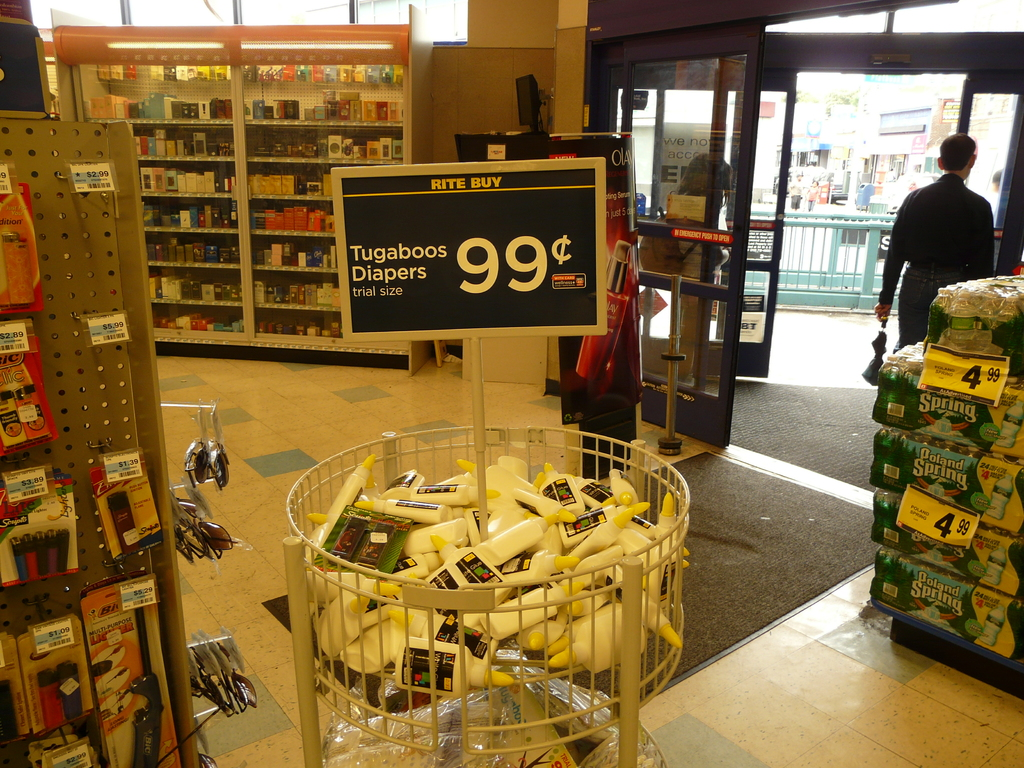What are some of the other items on sale in the image? In addition to Tugaboos Diapers with a sign indicating a price tag of $4.99, there are cases of Poland Spring bottled water on sale for the same price, as well as various sundries and personal care items in a nearby clearance bin priced at $2.99. 